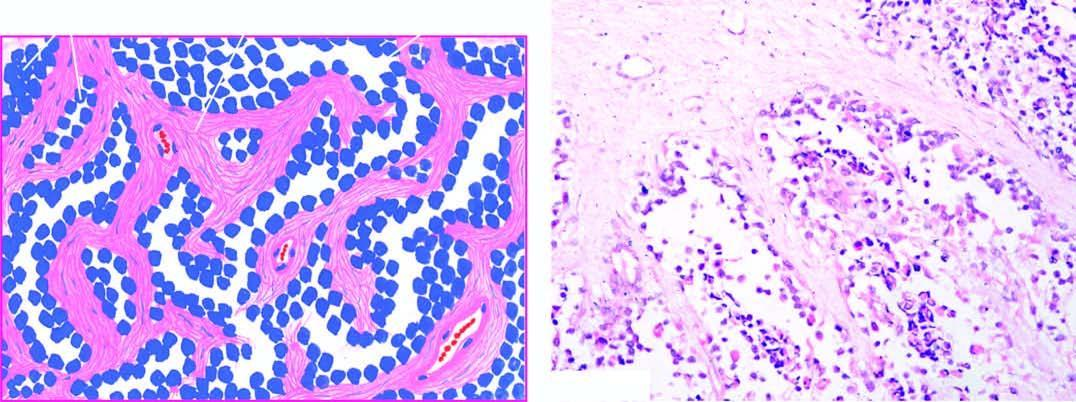what are lined by small, dark, undifferentiated tumour cells, with some cells floating in the alveolar spaces?
Answer the question using a single word or phrase. Fibrous trabeculae 